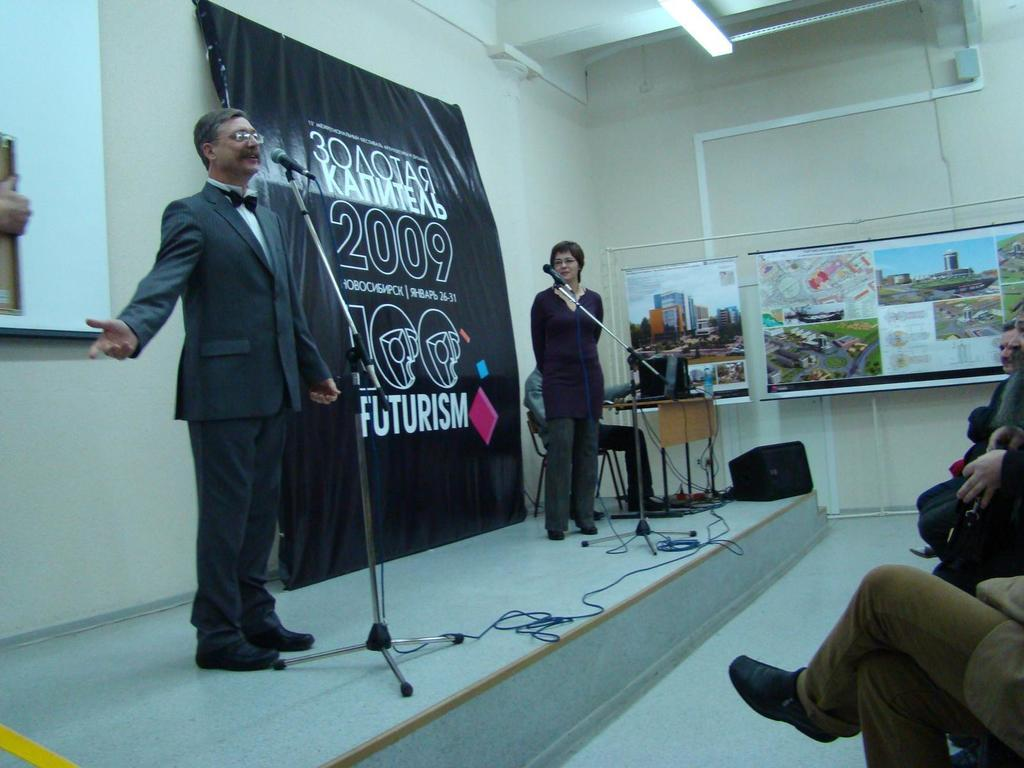Provide a one-sentence caption for the provided image. A man speaks on stage at a 2009 Futurism conference. 